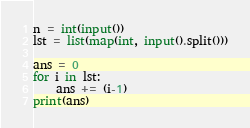<code> <loc_0><loc_0><loc_500><loc_500><_Python_>n = int(input())
lst = list(map(int, input().split()))

ans = 0
for i in lst:
    ans += (i-1)
print(ans)</code> 